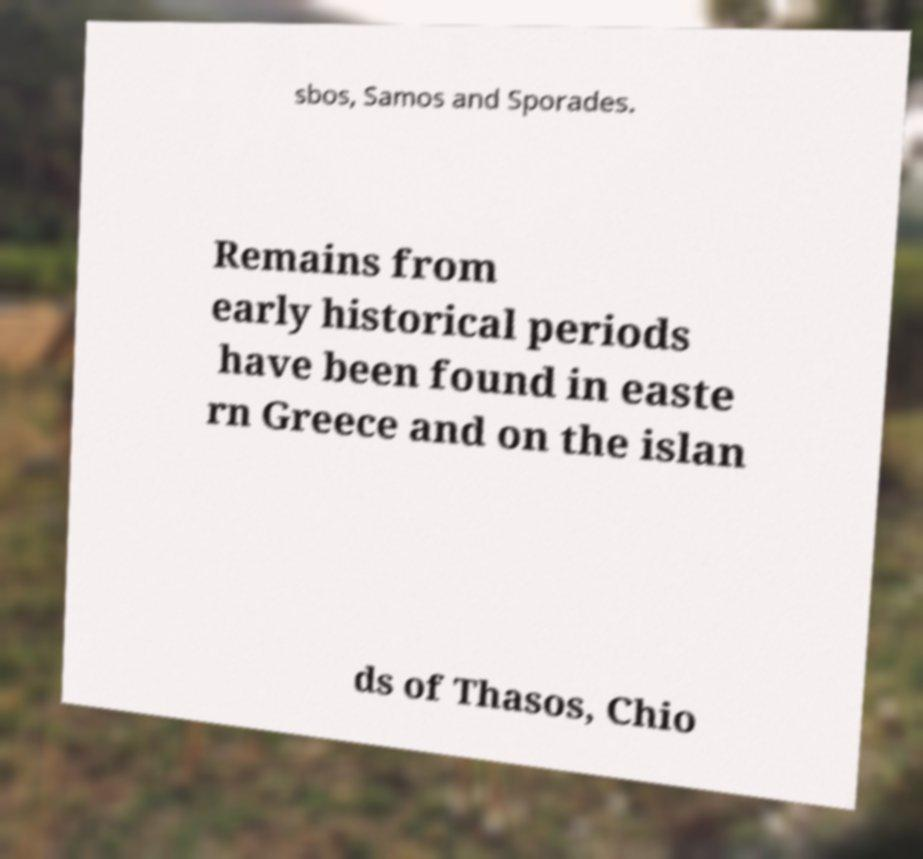Please read and relay the text visible in this image. What does it say? sbos, Samos and Sporades. Remains from early historical periods have been found in easte rn Greece and on the islan ds of Thasos, Chio 